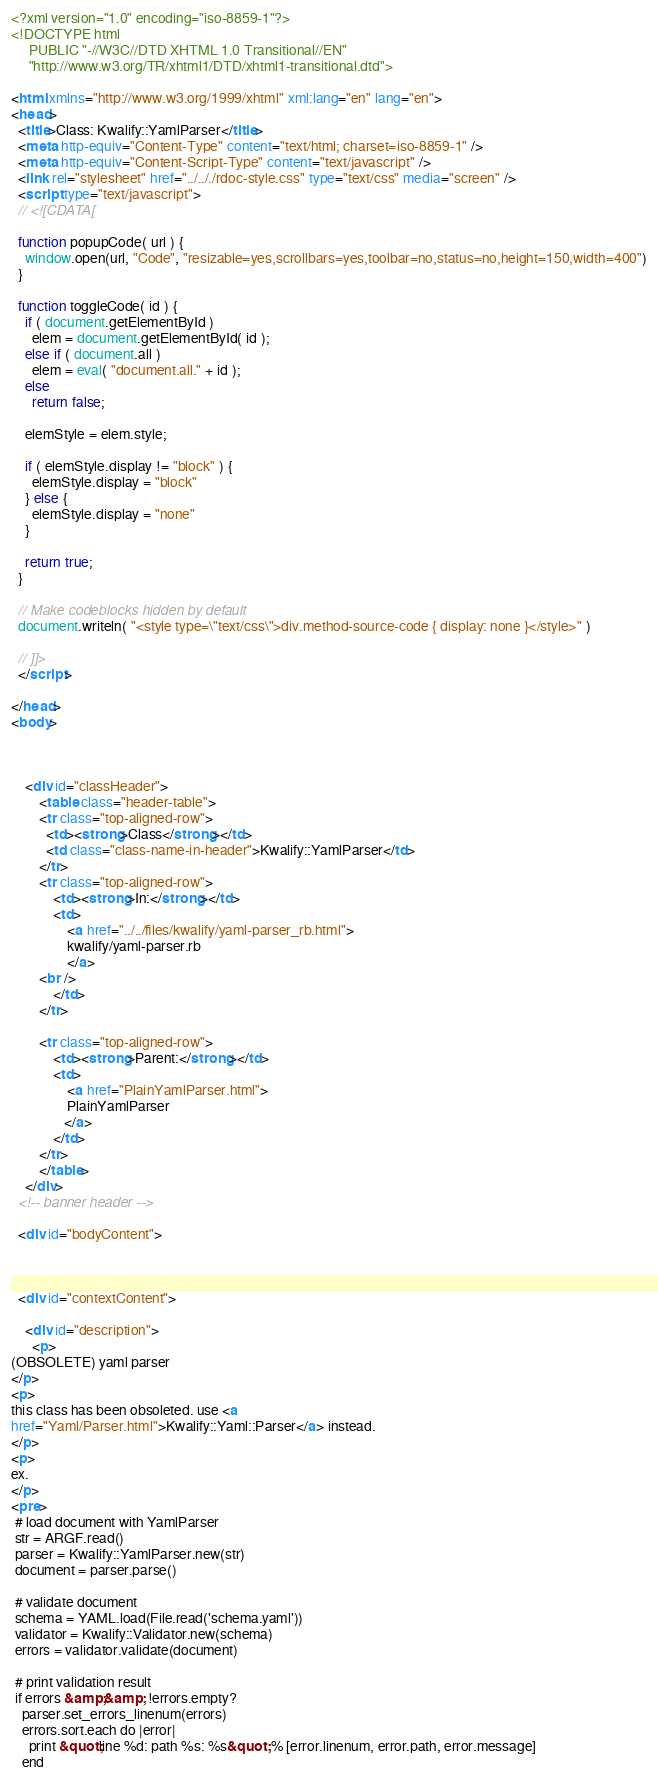Convert code to text. <code><loc_0><loc_0><loc_500><loc_500><_HTML_><?xml version="1.0" encoding="iso-8859-1"?>
<!DOCTYPE html 
     PUBLIC "-//W3C//DTD XHTML 1.0 Transitional//EN"
     "http://www.w3.org/TR/xhtml1/DTD/xhtml1-transitional.dtd">

<html xmlns="http://www.w3.org/1999/xhtml" xml:lang="en" lang="en">
<head>
  <title>Class: Kwalify::YamlParser</title>
  <meta http-equiv="Content-Type" content="text/html; charset=iso-8859-1" />
  <meta http-equiv="Content-Script-Type" content="text/javascript" />
  <link rel="stylesheet" href="../.././rdoc-style.css" type="text/css" media="screen" />
  <script type="text/javascript">
  // <![CDATA[

  function popupCode( url ) {
    window.open(url, "Code", "resizable=yes,scrollbars=yes,toolbar=no,status=no,height=150,width=400")
  }

  function toggleCode( id ) {
    if ( document.getElementById )
      elem = document.getElementById( id );
    else if ( document.all )
      elem = eval( "document.all." + id );
    else
      return false;

    elemStyle = elem.style;
    
    if ( elemStyle.display != "block" ) {
      elemStyle.display = "block"
    } else {
      elemStyle.display = "none"
    }

    return true;
  }
  
  // Make codeblocks hidden by default
  document.writeln( "<style type=\"text/css\">div.method-source-code { display: none }</style>" )
  
  // ]]>
  </script>

</head>
<body>



    <div id="classHeader">
        <table class="header-table">
        <tr class="top-aligned-row">
          <td><strong>Class</strong></td>
          <td class="class-name-in-header">Kwalify::YamlParser</td>
        </tr>
        <tr class="top-aligned-row">
            <td><strong>In:</strong></td>
            <td>
                <a href="../../files/kwalify/yaml-parser_rb.html">
                kwalify/yaml-parser.rb
                </a>
        <br />
            </td>
        </tr>

        <tr class="top-aligned-row">
            <td><strong>Parent:</strong></td>
            <td>
                <a href="PlainYamlParser.html">
                PlainYamlParser
               </a>
            </td>
        </tr>
        </table>
    </div>
  <!-- banner header -->

  <div id="bodyContent">



  <div id="contextContent">

    <div id="description">
      <p>
(OBSOLETE) yaml parser
</p>
<p>
this class has been obsoleted. use <a
href="Yaml/Parser.html">Kwalify::Yaml::Parser</a> instead.
</p>
<p>
ex.
</p>
<pre>
 # load document with YamlParser
 str = ARGF.read()
 parser = Kwalify::YamlParser.new(str)
 document = parser.parse()

 # validate document
 schema = YAML.load(File.read('schema.yaml'))
 validator = Kwalify::Validator.new(schema)
 errors = validator.validate(document)

 # print validation result
 if errors &amp;&amp; !errors.empty?
   parser.set_errors_linenum(errors)
   errors.sort.each do |error|
     print &quot;line %d: path %s: %s&quot; % [error.linenum, error.path, error.message]
   end</code> 